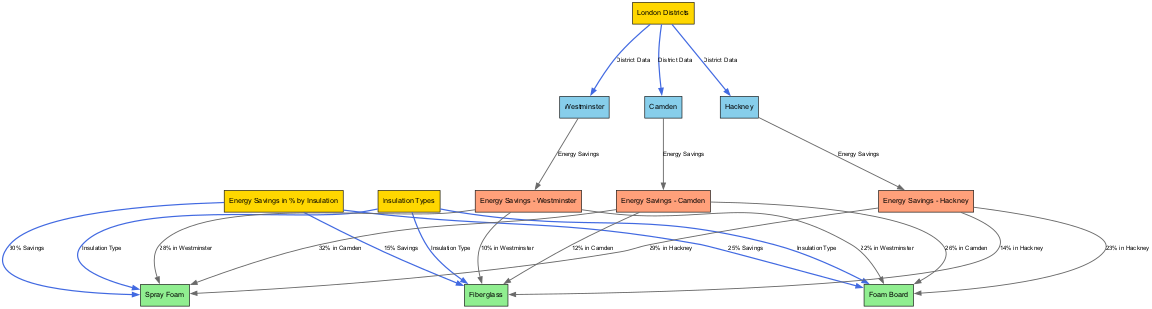What are the three districts compared in the diagram? The diagram lists three specific districts in London: Westminster, Camden, and Hackney. These districts are represented as nodes in the graph, clearly distinguishing them from others.
Answer: Westminster, Camden, Hackney What is the insulation type that shows the highest energy savings? The graph indicates that Spray Foam offers the highest energy savings at 30%. This value is shown in a labeled edge connecting the Spray Foam node to the energy savings node.
Answer: 30% How much energy savings does Foam Board provide in Camden? The diagram shows that Foam Board provides 26% energy savings when we look specifically at the Camden district. There is a direct connection on the graph indicating this percentage.
Answer: 26% Which district has the lowest energy savings for Fiberglass insulation? The diagram shows that Westminster has the lowest energy savings for Fiberglass insulation, with a value of 10%. This is indicated by the edge connecting Fiberglass to Westminster’s energy savings node.
Answer: 10% How many types of insulation are represented in the diagram? The diagram includes three types of insulation: Fiberglass, Foam Board, and Spray Foam. Each type is represented as a distinct node connected to the "Insulation Types" node.
Answer: Three What is the energy savings percentage for Hackney with Spray Foam? According to the diagram, Hackney benefits from a 29% energy savings when using Spray Foam. This information is obtained from the connection between the Spray Foam node and the Hackney energy savings node.
Answer: 29% Which insulation type provides energy savings of 25%? The diagram explicitly states that Foam Board provides 25% energy savings, as indicated by the edge linking it to the overall energy savings information.
Answer: 25% Which district has the highest overall energy savings for Spray Foam? Camden shows the highest energy savings for Spray Foam at 32%, as per the connections in the diagram that detail energy savings for each district by insulation type.
Answer: Camden What percent energy savings does Fiberglass insulation show in Hackney? The diagram indicates that Fiberglass insulation leads to 14% energy savings in Hackney, which is shown through the edge linking Fiberglass to the energy savings data for that district.
Answer: 14% 